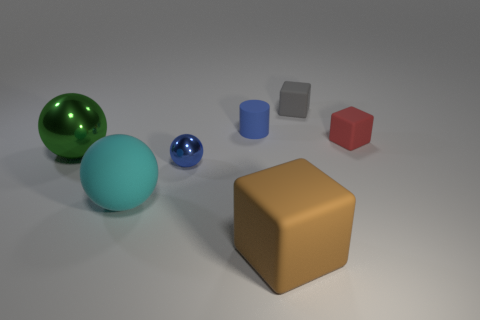Subtract all large balls. How many balls are left? 1 Add 1 blue balls. How many objects exist? 8 Subtract 2 blocks. How many blocks are left? 1 Subtract all cubes. How many objects are left? 4 Subtract all blue balls. How many balls are left? 2 Subtract all purple cubes. Subtract all cyan spheres. How many cubes are left? 3 Subtract all tiny gray objects. Subtract all cyan spheres. How many objects are left? 5 Add 4 blue rubber things. How many blue rubber things are left? 5 Add 3 metal things. How many metal things exist? 5 Subtract 0 gray spheres. How many objects are left? 7 